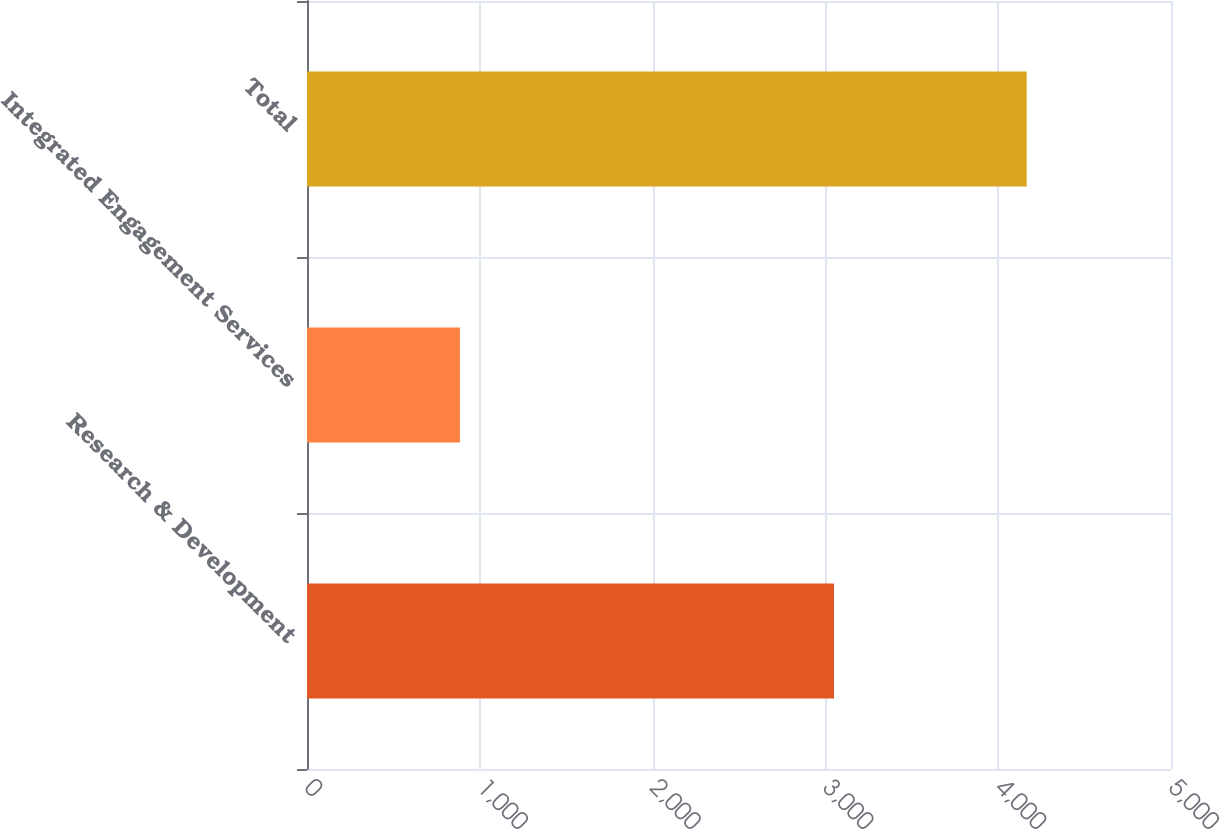Convert chart to OTSL. <chart><loc_0><loc_0><loc_500><loc_500><bar_chart><fcel>Research & Development<fcel>Integrated Engagement Services<fcel>Total<nl><fcel>3050<fcel>885<fcel>4165<nl></chart> 